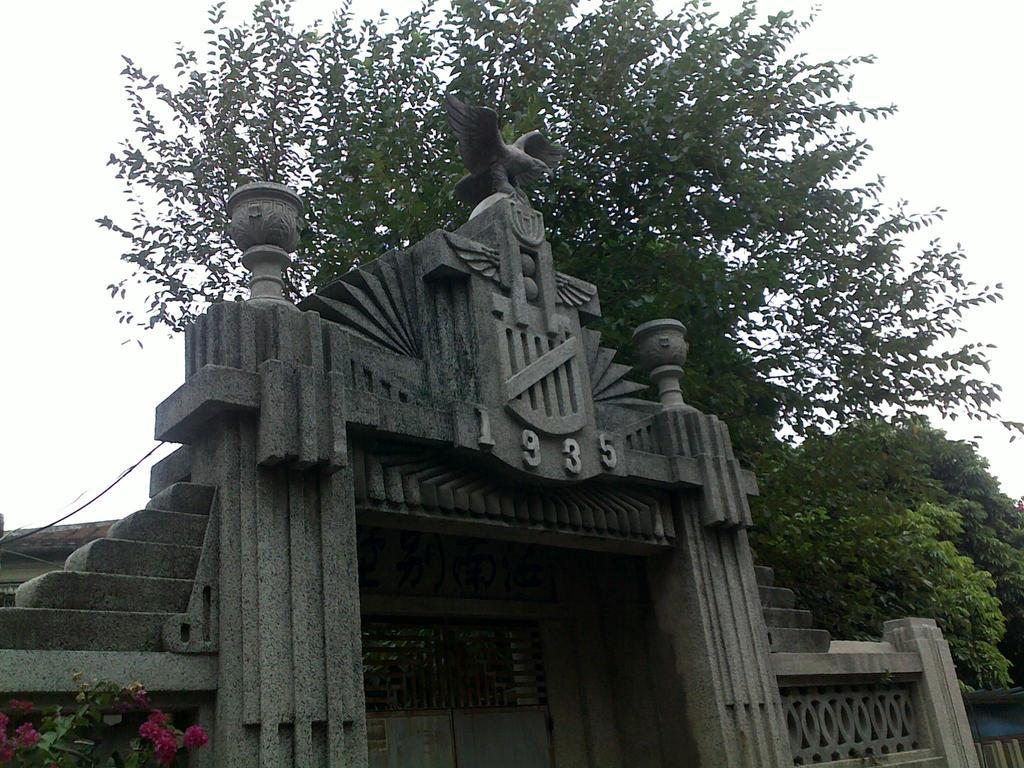<image>
Present a compact description of the photo's key features. A gothic stone facade displays the number 1935 above the doorway. 